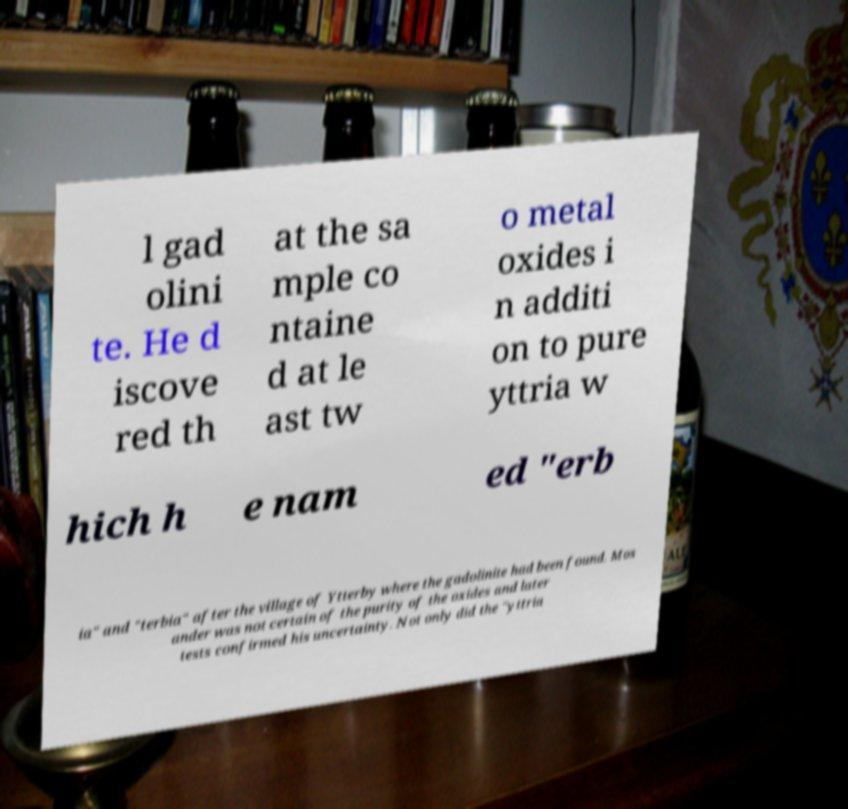What messages or text are displayed in this image? I need them in a readable, typed format. l gad olini te. He d iscove red th at the sa mple co ntaine d at le ast tw o metal oxides i n additi on to pure yttria w hich h e nam ed "erb ia" and "terbia" after the village of Ytterby where the gadolinite had been found. Mos ander was not certain of the purity of the oxides and later tests confirmed his uncertainty. Not only did the "yttria 